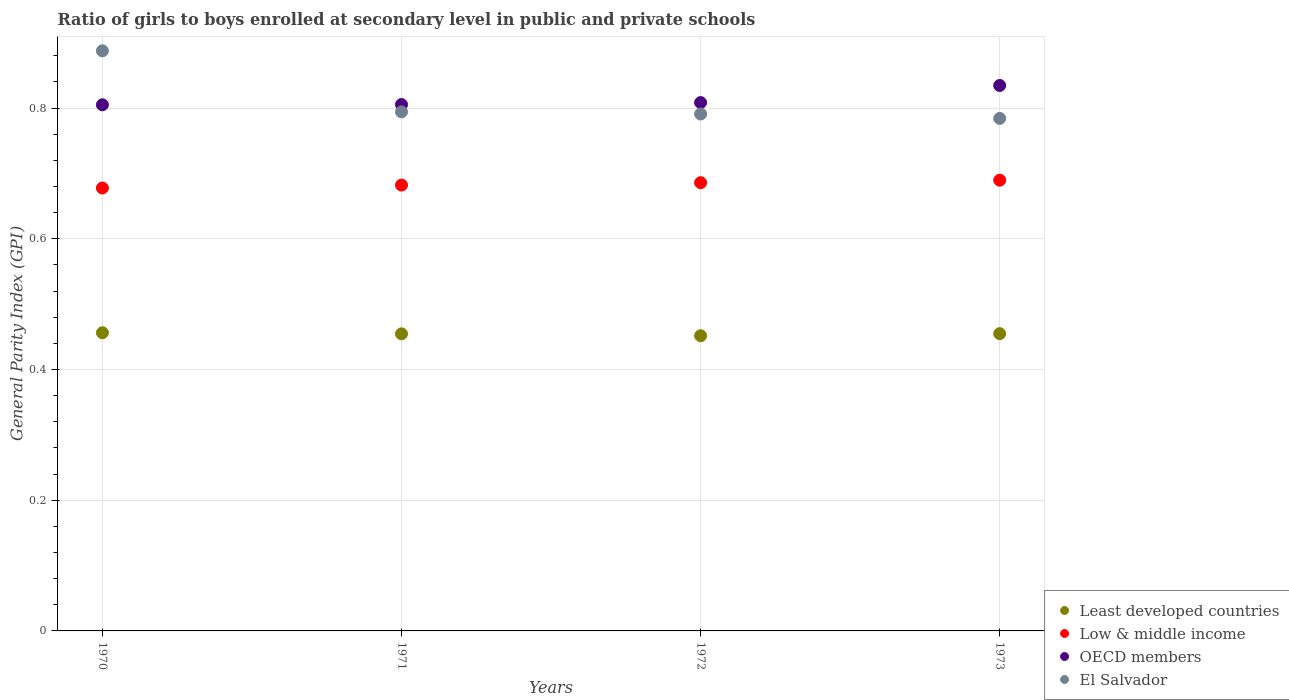How many different coloured dotlines are there?
Offer a terse response. 4. Is the number of dotlines equal to the number of legend labels?
Your answer should be compact. Yes. What is the general parity index in Least developed countries in 1970?
Offer a very short reply. 0.46. Across all years, what is the maximum general parity index in OECD members?
Your answer should be very brief. 0.83. Across all years, what is the minimum general parity index in El Salvador?
Provide a succinct answer. 0.78. What is the total general parity index in Low & middle income in the graph?
Provide a succinct answer. 2.74. What is the difference between the general parity index in El Salvador in 1970 and that in 1971?
Your answer should be very brief. 0.09. What is the difference between the general parity index in El Salvador in 1973 and the general parity index in Least developed countries in 1971?
Make the answer very short. 0.33. What is the average general parity index in El Salvador per year?
Provide a succinct answer. 0.81. In the year 1973, what is the difference between the general parity index in El Salvador and general parity index in OECD members?
Provide a succinct answer. -0.05. What is the ratio of the general parity index in OECD members in 1971 to that in 1972?
Your answer should be very brief. 1. Is the general parity index in OECD members in 1972 less than that in 1973?
Ensure brevity in your answer.  Yes. What is the difference between the highest and the second highest general parity index in El Salvador?
Provide a succinct answer. 0.09. What is the difference between the highest and the lowest general parity index in Least developed countries?
Keep it short and to the point. 0. Is the sum of the general parity index in OECD members in 1970 and 1971 greater than the maximum general parity index in Low & middle income across all years?
Your answer should be compact. Yes. Is it the case that in every year, the sum of the general parity index in OECD members and general parity index in Least developed countries  is greater than the sum of general parity index in Low & middle income and general parity index in El Salvador?
Your answer should be very brief. No. Is it the case that in every year, the sum of the general parity index in OECD members and general parity index in El Salvador  is greater than the general parity index in Low & middle income?
Your answer should be compact. Yes. Does the general parity index in Low & middle income monotonically increase over the years?
Keep it short and to the point. Yes. Is the general parity index in Least developed countries strictly greater than the general parity index in Low & middle income over the years?
Provide a short and direct response. No. Is the general parity index in Least developed countries strictly less than the general parity index in OECD members over the years?
Offer a very short reply. Yes. How many dotlines are there?
Your answer should be very brief. 4. How many years are there in the graph?
Your response must be concise. 4. How are the legend labels stacked?
Make the answer very short. Vertical. What is the title of the graph?
Give a very brief answer. Ratio of girls to boys enrolled at secondary level in public and private schools. What is the label or title of the Y-axis?
Give a very brief answer. General Parity Index (GPI). What is the General Parity Index (GPI) of Least developed countries in 1970?
Your response must be concise. 0.46. What is the General Parity Index (GPI) in Low & middle income in 1970?
Ensure brevity in your answer.  0.68. What is the General Parity Index (GPI) of OECD members in 1970?
Your answer should be very brief. 0.81. What is the General Parity Index (GPI) in El Salvador in 1970?
Keep it short and to the point. 0.89. What is the General Parity Index (GPI) in Least developed countries in 1971?
Provide a succinct answer. 0.45. What is the General Parity Index (GPI) of Low & middle income in 1971?
Offer a very short reply. 0.68. What is the General Parity Index (GPI) in OECD members in 1971?
Your response must be concise. 0.81. What is the General Parity Index (GPI) of El Salvador in 1971?
Provide a short and direct response. 0.79. What is the General Parity Index (GPI) of Least developed countries in 1972?
Make the answer very short. 0.45. What is the General Parity Index (GPI) in Low & middle income in 1972?
Your answer should be compact. 0.69. What is the General Parity Index (GPI) in OECD members in 1972?
Offer a very short reply. 0.81. What is the General Parity Index (GPI) of El Salvador in 1972?
Keep it short and to the point. 0.79. What is the General Parity Index (GPI) in Least developed countries in 1973?
Your answer should be very brief. 0.45. What is the General Parity Index (GPI) in Low & middle income in 1973?
Provide a short and direct response. 0.69. What is the General Parity Index (GPI) of OECD members in 1973?
Provide a short and direct response. 0.83. What is the General Parity Index (GPI) in El Salvador in 1973?
Your response must be concise. 0.78. Across all years, what is the maximum General Parity Index (GPI) in Least developed countries?
Provide a succinct answer. 0.46. Across all years, what is the maximum General Parity Index (GPI) in Low & middle income?
Ensure brevity in your answer.  0.69. Across all years, what is the maximum General Parity Index (GPI) of OECD members?
Keep it short and to the point. 0.83. Across all years, what is the maximum General Parity Index (GPI) of El Salvador?
Give a very brief answer. 0.89. Across all years, what is the minimum General Parity Index (GPI) of Least developed countries?
Keep it short and to the point. 0.45. Across all years, what is the minimum General Parity Index (GPI) in Low & middle income?
Provide a short and direct response. 0.68. Across all years, what is the minimum General Parity Index (GPI) of OECD members?
Keep it short and to the point. 0.81. Across all years, what is the minimum General Parity Index (GPI) of El Salvador?
Your answer should be very brief. 0.78. What is the total General Parity Index (GPI) of Least developed countries in the graph?
Your response must be concise. 1.82. What is the total General Parity Index (GPI) of Low & middle income in the graph?
Provide a short and direct response. 2.74. What is the total General Parity Index (GPI) in OECD members in the graph?
Keep it short and to the point. 3.25. What is the total General Parity Index (GPI) in El Salvador in the graph?
Offer a terse response. 3.26. What is the difference between the General Parity Index (GPI) of Least developed countries in 1970 and that in 1971?
Your answer should be compact. 0. What is the difference between the General Parity Index (GPI) in Low & middle income in 1970 and that in 1971?
Keep it short and to the point. -0. What is the difference between the General Parity Index (GPI) of OECD members in 1970 and that in 1971?
Give a very brief answer. -0. What is the difference between the General Parity Index (GPI) of El Salvador in 1970 and that in 1971?
Your answer should be very brief. 0.09. What is the difference between the General Parity Index (GPI) of Least developed countries in 1970 and that in 1972?
Provide a succinct answer. 0. What is the difference between the General Parity Index (GPI) of Low & middle income in 1970 and that in 1972?
Your answer should be compact. -0.01. What is the difference between the General Parity Index (GPI) of OECD members in 1970 and that in 1972?
Offer a very short reply. -0. What is the difference between the General Parity Index (GPI) of El Salvador in 1970 and that in 1972?
Your response must be concise. 0.1. What is the difference between the General Parity Index (GPI) of Least developed countries in 1970 and that in 1973?
Provide a short and direct response. 0. What is the difference between the General Parity Index (GPI) of Low & middle income in 1970 and that in 1973?
Provide a short and direct response. -0.01. What is the difference between the General Parity Index (GPI) in OECD members in 1970 and that in 1973?
Offer a very short reply. -0.03. What is the difference between the General Parity Index (GPI) of El Salvador in 1970 and that in 1973?
Provide a short and direct response. 0.1. What is the difference between the General Parity Index (GPI) in Least developed countries in 1971 and that in 1972?
Offer a terse response. 0. What is the difference between the General Parity Index (GPI) in Low & middle income in 1971 and that in 1972?
Keep it short and to the point. -0. What is the difference between the General Parity Index (GPI) in OECD members in 1971 and that in 1972?
Your answer should be compact. -0. What is the difference between the General Parity Index (GPI) in El Salvador in 1971 and that in 1972?
Offer a terse response. 0. What is the difference between the General Parity Index (GPI) of Least developed countries in 1971 and that in 1973?
Offer a very short reply. -0. What is the difference between the General Parity Index (GPI) of Low & middle income in 1971 and that in 1973?
Offer a terse response. -0.01. What is the difference between the General Parity Index (GPI) in OECD members in 1971 and that in 1973?
Offer a terse response. -0.03. What is the difference between the General Parity Index (GPI) of Least developed countries in 1972 and that in 1973?
Offer a very short reply. -0. What is the difference between the General Parity Index (GPI) of Low & middle income in 1972 and that in 1973?
Give a very brief answer. -0. What is the difference between the General Parity Index (GPI) of OECD members in 1972 and that in 1973?
Keep it short and to the point. -0.03. What is the difference between the General Parity Index (GPI) of El Salvador in 1972 and that in 1973?
Ensure brevity in your answer.  0.01. What is the difference between the General Parity Index (GPI) of Least developed countries in 1970 and the General Parity Index (GPI) of Low & middle income in 1971?
Ensure brevity in your answer.  -0.23. What is the difference between the General Parity Index (GPI) of Least developed countries in 1970 and the General Parity Index (GPI) of OECD members in 1971?
Your answer should be very brief. -0.35. What is the difference between the General Parity Index (GPI) of Least developed countries in 1970 and the General Parity Index (GPI) of El Salvador in 1971?
Make the answer very short. -0.34. What is the difference between the General Parity Index (GPI) of Low & middle income in 1970 and the General Parity Index (GPI) of OECD members in 1971?
Provide a succinct answer. -0.13. What is the difference between the General Parity Index (GPI) in Low & middle income in 1970 and the General Parity Index (GPI) in El Salvador in 1971?
Your answer should be compact. -0.12. What is the difference between the General Parity Index (GPI) in OECD members in 1970 and the General Parity Index (GPI) in El Salvador in 1971?
Make the answer very short. 0.01. What is the difference between the General Parity Index (GPI) in Least developed countries in 1970 and the General Parity Index (GPI) in Low & middle income in 1972?
Your answer should be compact. -0.23. What is the difference between the General Parity Index (GPI) in Least developed countries in 1970 and the General Parity Index (GPI) in OECD members in 1972?
Provide a succinct answer. -0.35. What is the difference between the General Parity Index (GPI) of Least developed countries in 1970 and the General Parity Index (GPI) of El Salvador in 1972?
Your answer should be very brief. -0.33. What is the difference between the General Parity Index (GPI) of Low & middle income in 1970 and the General Parity Index (GPI) of OECD members in 1972?
Ensure brevity in your answer.  -0.13. What is the difference between the General Parity Index (GPI) in Low & middle income in 1970 and the General Parity Index (GPI) in El Salvador in 1972?
Your answer should be compact. -0.11. What is the difference between the General Parity Index (GPI) of OECD members in 1970 and the General Parity Index (GPI) of El Salvador in 1972?
Provide a succinct answer. 0.01. What is the difference between the General Parity Index (GPI) of Least developed countries in 1970 and the General Parity Index (GPI) of Low & middle income in 1973?
Your response must be concise. -0.23. What is the difference between the General Parity Index (GPI) of Least developed countries in 1970 and the General Parity Index (GPI) of OECD members in 1973?
Offer a terse response. -0.38. What is the difference between the General Parity Index (GPI) of Least developed countries in 1970 and the General Parity Index (GPI) of El Salvador in 1973?
Keep it short and to the point. -0.33. What is the difference between the General Parity Index (GPI) of Low & middle income in 1970 and the General Parity Index (GPI) of OECD members in 1973?
Give a very brief answer. -0.16. What is the difference between the General Parity Index (GPI) in Low & middle income in 1970 and the General Parity Index (GPI) in El Salvador in 1973?
Keep it short and to the point. -0.11. What is the difference between the General Parity Index (GPI) in OECD members in 1970 and the General Parity Index (GPI) in El Salvador in 1973?
Your answer should be very brief. 0.02. What is the difference between the General Parity Index (GPI) of Least developed countries in 1971 and the General Parity Index (GPI) of Low & middle income in 1972?
Your response must be concise. -0.23. What is the difference between the General Parity Index (GPI) in Least developed countries in 1971 and the General Parity Index (GPI) in OECD members in 1972?
Ensure brevity in your answer.  -0.35. What is the difference between the General Parity Index (GPI) in Least developed countries in 1971 and the General Parity Index (GPI) in El Salvador in 1972?
Offer a very short reply. -0.34. What is the difference between the General Parity Index (GPI) of Low & middle income in 1971 and the General Parity Index (GPI) of OECD members in 1972?
Your answer should be compact. -0.13. What is the difference between the General Parity Index (GPI) in Low & middle income in 1971 and the General Parity Index (GPI) in El Salvador in 1972?
Keep it short and to the point. -0.11. What is the difference between the General Parity Index (GPI) in OECD members in 1971 and the General Parity Index (GPI) in El Salvador in 1972?
Offer a terse response. 0.01. What is the difference between the General Parity Index (GPI) of Least developed countries in 1971 and the General Parity Index (GPI) of Low & middle income in 1973?
Ensure brevity in your answer.  -0.24. What is the difference between the General Parity Index (GPI) of Least developed countries in 1971 and the General Parity Index (GPI) of OECD members in 1973?
Give a very brief answer. -0.38. What is the difference between the General Parity Index (GPI) of Least developed countries in 1971 and the General Parity Index (GPI) of El Salvador in 1973?
Provide a succinct answer. -0.33. What is the difference between the General Parity Index (GPI) of Low & middle income in 1971 and the General Parity Index (GPI) of OECD members in 1973?
Offer a terse response. -0.15. What is the difference between the General Parity Index (GPI) in Low & middle income in 1971 and the General Parity Index (GPI) in El Salvador in 1973?
Your answer should be compact. -0.1. What is the difference between the General Parity Index (GPI) in OECD members in 1971 and the General Parity Index (GPI) in El Salvador in 1973?
Your response must be concise. 0.02. What is the difference between the General Parity Index (GPI) in Least developed countries in 1972 and the General Parity Index (GPI) in Low & middle income in 1973?
Provide a succinct answer. -0.24. What is the difference between the General Parity Index (GPI) of Least developed countries in 1972 and the General Parity Index (GPI) of OECD members in 1973?
Ensure brevity in your answer.  -0.38. What is the difference between the General Parity Index (GPI) of Least developed countries in 1972 and the General Parity Index (GPI) of El Salvador in 1973?
Ensure brevity in your answer.  -0.33. What is the difference between the General Parity Index (GPI) in Low & middle income in 1972 and the General Parity Index (GPI) in OECD members in 1973?
Your answer should be very brief. -0.15. What is the difference between the General Parity Index (GPI) in Low & middle income in 1972 and the General Parity Index (GPI) in El Salvador in 1973?
Provide a succinct answer. -0.1. What is the difference between the General Parity Index (GPI) of OECD members in 1972 and the General Parity Index (GPI) of El Salvador in 1973?
Provide a short and direct response. 0.02. What is the average General Parity Index (GPI) in Least developed countries per year?
Ensure brevity in your answer.  0.45. What is the average General Parity Index (GPI) in Low & middle income per year?
Ensure brevity in your answer.  0.68. What is the average General Parity Index (GPI) of OECD members per year?
Ensure brevity in your answer.  0.81. What is the average General Parity Index (GPI) in El Salvador per year?
Give a very brief answer. 0.81. In the year 1970, what is the difference between the General Parity Index (GPI) of Least developed countries and General Parity Index (GPI) of Low & middle income?
Offer a terse response. -0.22. In the year 1970, what is the difference between the General Parity Index (GPI) in Least developed countries and General Parity Index (GPI) in OECD members?
Keep it short and to the point. -0.35. In the year 1970, what is the difference between the General Parity Index (GPI) of Least developed countries and General Parity Index (GPI) of El Salvador?
Make the answer very short. -0.43. In the year 1970, what is the difference between the General Parity Index (GPI) in Low & middle income and General Parity Index (GPI) in OECD members?
Offer a terse response. -0.13. In the year 1970, what is the difference between the General Parity Index (GPI) in Low & middle income and General Parity Index (GPI) in El Salvador?
Give a very brief answer. -0.21. In the year 1970, what is the difference between the General Parity Index (GPI) of OECD members and General Parity Index (GPI) of El Salvador?
Offer a terse response. -0.08. In the year 1971, what is the difference between the General Parity Index (GPI) of Least developed countries and General Parity Index (GPI) of Low & middle income?
Your answer should be very brief. -0.23. In the year 1971, what is the difference between the General Parity Index (GPI) of Least developed countries and General Parity Index (GPI) of OECD members?
Your answer should be very brief. -0.35. In the year 1971, what is the difference between the General Parity Index (GPI) of Least developed countries and General Parity Index (GPI) of El Salvador?
Provide a succinct answer. -0.34. In the year 1971, what is the difference between the General Parity Index (GPI) of Low & middle income and General Parity Index (GPI) of OECD members?
Keep it short and to the point. -0.12. In the year 1971, what is the difference between the General Parity Index (GPI) of Low & middle income and General Parity Index (GPI) of El Salvador?
Make the answer very short. -0.11. In the year 1971, what is the difference between the General Parity Index (GPI) of OECD members and General Parity Index (GPI) of El Salvador?
Your response must be concise. 0.01. In the year 1972, what is the difference between the General Parity Index (GPI) in Least developed countries and General Parity Index (GPI) in Low & middle income?
Offer a terse response. -0.23. In the year 1972, what is the difference between the General Parity Index (GPI) in Least developed countries and General Parity Index (GPI) in OECD members?
Ensure brevity in your answer.  -0.36. In the year 1972, what is the difference between the General Parity Index (GPI) in Least developed countries and General Parity Index (GPI) in El Salvador?
Provide a short and direct response. -0.34. In the year 1972, what is the difference between the General Parity Index (GPI) in Low & middle income and General Parity Index (GPI) in OECD members?
Your response must be concise. -0.12. In the year 1972, what is the difference between the General Parity Index (GPI) of Low & middle income and General Parity Index (GPI) of El Salvador?
Provide a succinct answer. -0.11. In the year 1972, what is the difference between the General Parity Index (GPI) in OECD members and General Parity Index (GPI) in El Salvador?
Your answer should be compact. 0.02. In the year 1973, what is the difference between the General Parity Index (GPI) in Least developed countries and General Parity Index (GPI) in Low & middle income?
Your answer should be compact. -0.23. In the year 1973, what is the difference between the General Parity Index (GPI) in Least developed countries and General Parity Index (GPI) in OECD members?
Provide a succinct answer. -0.38. In the year 1973, what is the difference between the General Parity Index (GPI) in Least developed countries and General Parity Index (GPI) in El Salvador?
Your answer should be very brief. -0.33. In the year 1973, what is the difference between the General Parity Index (GPI) in Low & middle income and General Parity Index (GPI) in OECD members?
Give a very brief answer. -0.14. In the year 1973, what is the difference between the General Parity Index (GPI) of Low & middle income and General Parity Index (GPI) of El Salvador?
Your answer should be very brief. -0.09. In the year 1973, what is the difference between the General Parity Index (GPI) in OECD members and General Parity Index (GPI) in El Salvador?
Provide a short and direct response. 0.05. What is the ratio of the General Parity Index (GPI) in Low & middle income in 1970 to that in 1971?
Ensure brevity in your answer.  0.99. What is the ratio of the General Parity Index (GPI) of OECD members in 1970 to that in 1971?
Offer a very short reply. 1. What is the ratio of the General Parity Index (GPI) in El Salvador in 1970 to that in 1971?
Offer a very short reply. 1.12. What is the ratio of the General Parity Index (GPI) in Least developed countries in 1970 to that in 1972?
Ensure brevity in your answer.  1.01. What is the ratio of the General Parity Index (GPI) of OECD members in 1970 to that in 1972?
Make the answer very short. 1. What is the ratio of the General Parity Index (GPI) of El Salvador in 1970 to that in 1972?
Keep it short and to the point. 1.12. What is the ratio of the General Parity Index (GPI) in Least developed countries in 1970 to that in 1973?
Offer a very short reply. 1. What is the ratio of the General Parity Index (GPI) in Low & middle income in 1970 to that in 1973?
Your answer should be compact. 0.98. What is the ratio of the General Parity Index (GPI) of OECD members in 1970 to that in 1973?
Keep it short and to the point. 0.96. What is the ratio of the General Parity Index (GPI) of El Salvador in 1970 to that in 1973?
Your answer should be very brief. 1.13. What is the ratio of the General Parity Index (GPI) of Least developed countries in 1971 to that in 1972?
Provide a succinct answer. 1.01. What is the ratio of the General Parity Index (GPI) in Low & middle income in 1971 to that in 1972?
Give a very brief answer. 0.99. What is the ratio of the General Parity Index (GPI) of OECD members in 1971 to that in 1972?
Offer a terse response. 1. What is the ratio of the General Parity Index (GPI) of Low & middle income in 1971 to that in 1973?
Offer a terse response. 0.99. What is the ratio of the General Parity Index (GPI) of OECD members in 1971 to that in 1973?
Provide a short and direct response. 0.97. What is the ratio of the General Parity Index (GPI) of El Salvador in 1971 to that in 1973?
Your answer should be very brief. 1.01. What is the ratio of the General Parity Index (GPI) in OECD members in 1972 to that in 1973?
Offer a very short reply. 0.97. What is the ratio of the General Parity Index (GPI) in El Salvador in 1972 to that in 1973?
Your answer should be very brief. 1.01. What is the difference between the highest and the second highest General Parity Index (GPI) in Least developed countries?
Offer a terse response. 0. What is the difference between the highest and the second highest General Parity Index (GPI) of Low & middle income?
Provide a short and direct response. 0. What is the difference between the highest and the second highest General Parity Index (GPI) in OECD members?
Offer a terse response. 0.03. What is the difference between the highest and the second highest General Parity Index (GPI) of El Salvador?
Offer a very short reply. 0.09. What is the difference between the highest and the lowest General Parity Index (GPI) of Least developed countries?
Ensure brevity in your answer.  0. What is the difference between the highest and the lowest General Parity Index (GPI) of Low & middle income?
Your answer should be compact. 0.01. What is the difference between the highest and the lowest General Parity Index (GPI) in OECD members?
Provide a short and direct response. 0.03. What is the difference between the highest and the lowest General Parity Index (GPI) in El Salvador?
Your answer should be very brief. 0.1. 